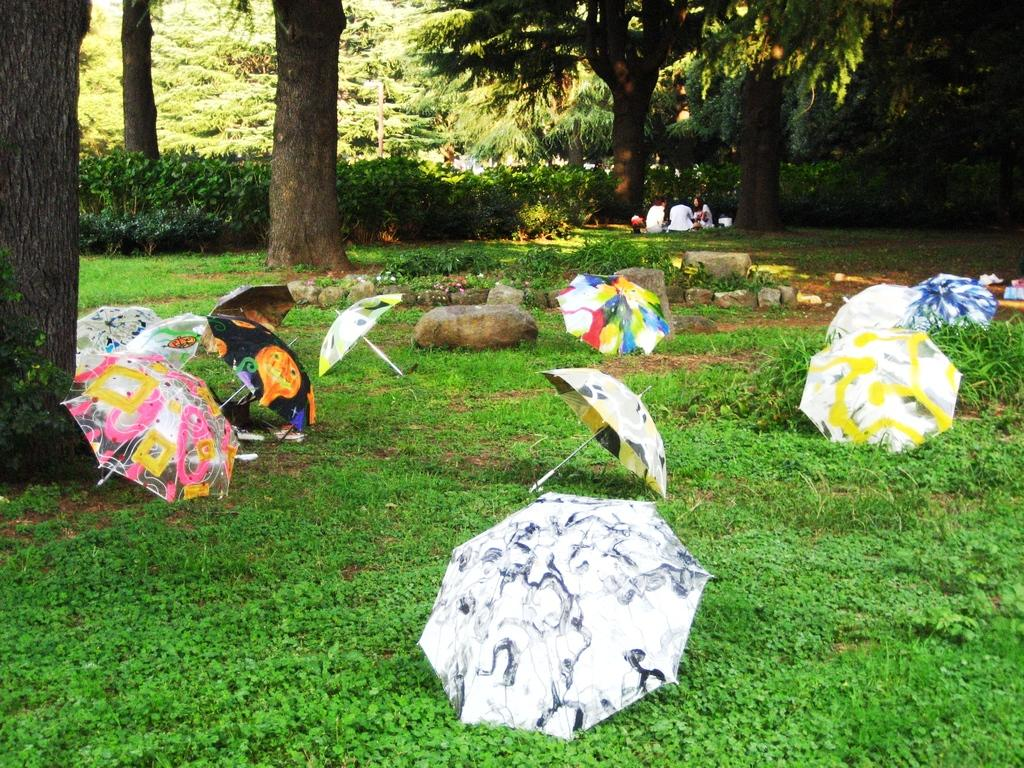What objects can be seen at the bottom of the image? There are umbrellas, stones, plants, flowers, and grass at the bottom of the image. What else can be found at the bottom of the image besides the mentioned objects? There are no other objects mentioned in the provided facts. What is located in the middle of the image? There are people, trees, and plants in the middle of the image. Can you describe the plants at the bottom of the image? The plants at the bottom of the image include flowers and other unspecified plants. What type of business is being conducted in the image? There is no indication of any business activity in the image. Can you see any worms crawling on the grass in the image? There is no mention of worms in the provided facts, and therefore no such activity can be observed. 